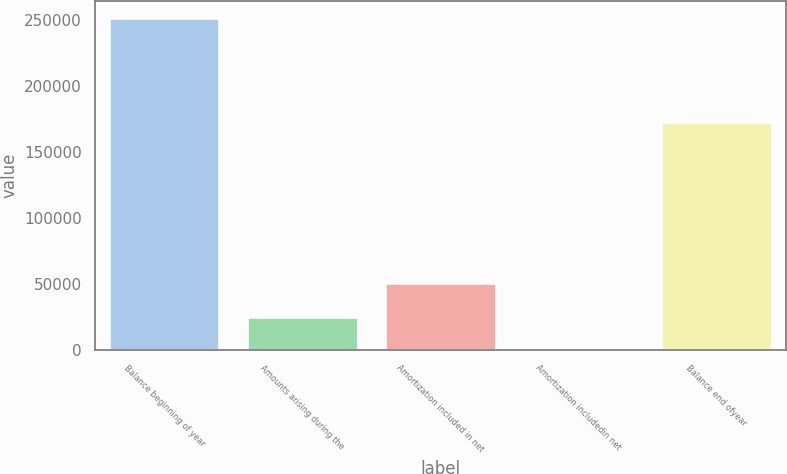<chart> <loc_0><loc_0><loc_500><loc_500><bar_chart><fcel>Balance beginning of year<fcel>Amounts arising during the<fcel>Amortization included in net<fcel>Amortization includedin net<fcel>Balance end ofyear<nl><fcel>251655<fcel>25420.2<fcel>50557.4<fcel>283<fcel>173029<nl></chart> 